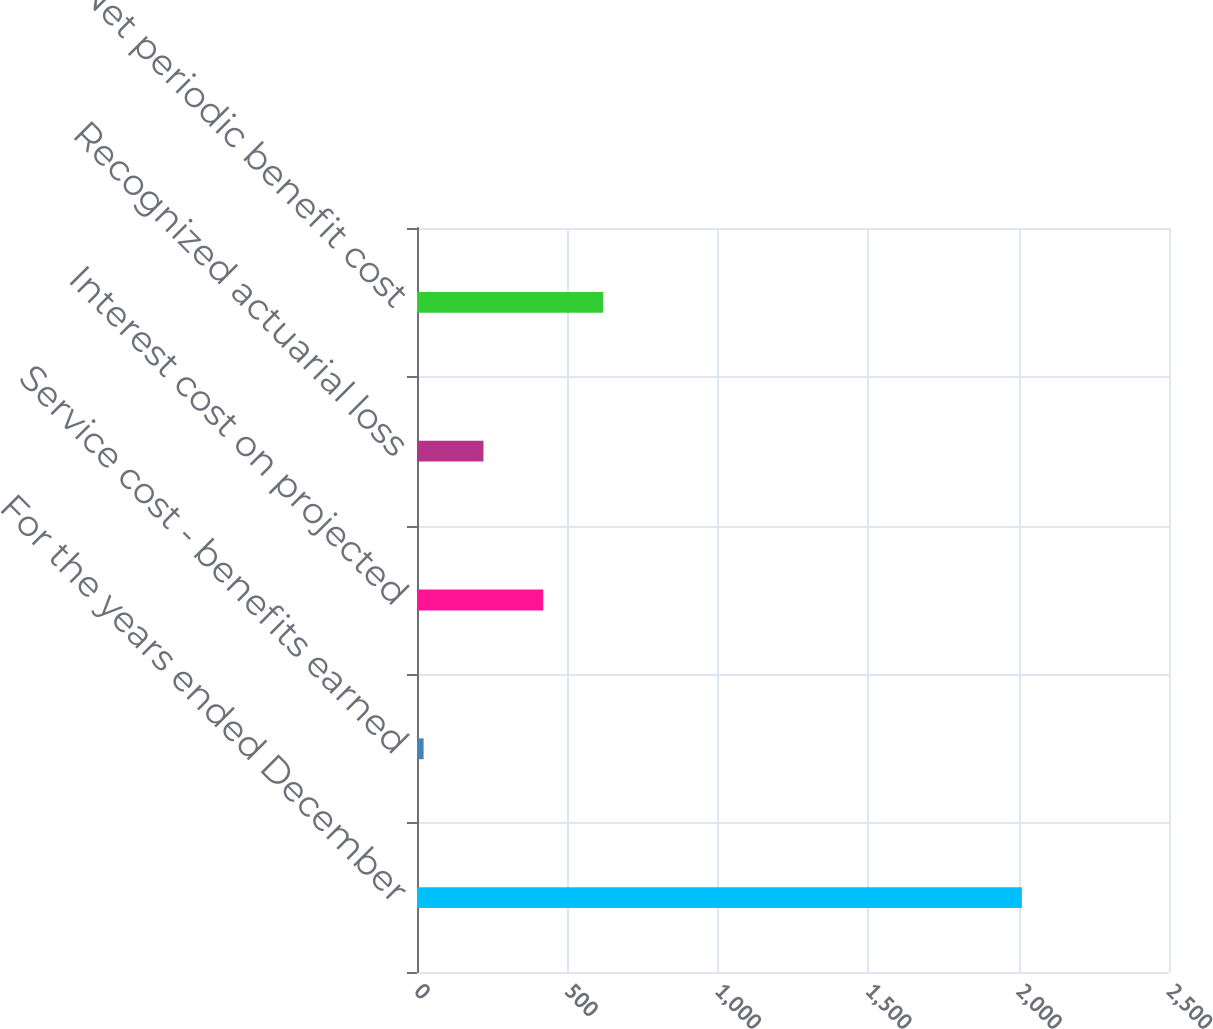Convert chart. <chart><loc_0><loc_0><loc_500><loc_500><bar_chart><fcel>For the years ended December<fcel>Service cost - benefits earned<fcel>Interest cost on projected<fcel>Recognized actuarial loss<fcel>Net periodic benefit cost<nl><fcel>2011<fcel>22<fcel>419.8<fcel>220.9<fcel>618.7<nl></chart> 